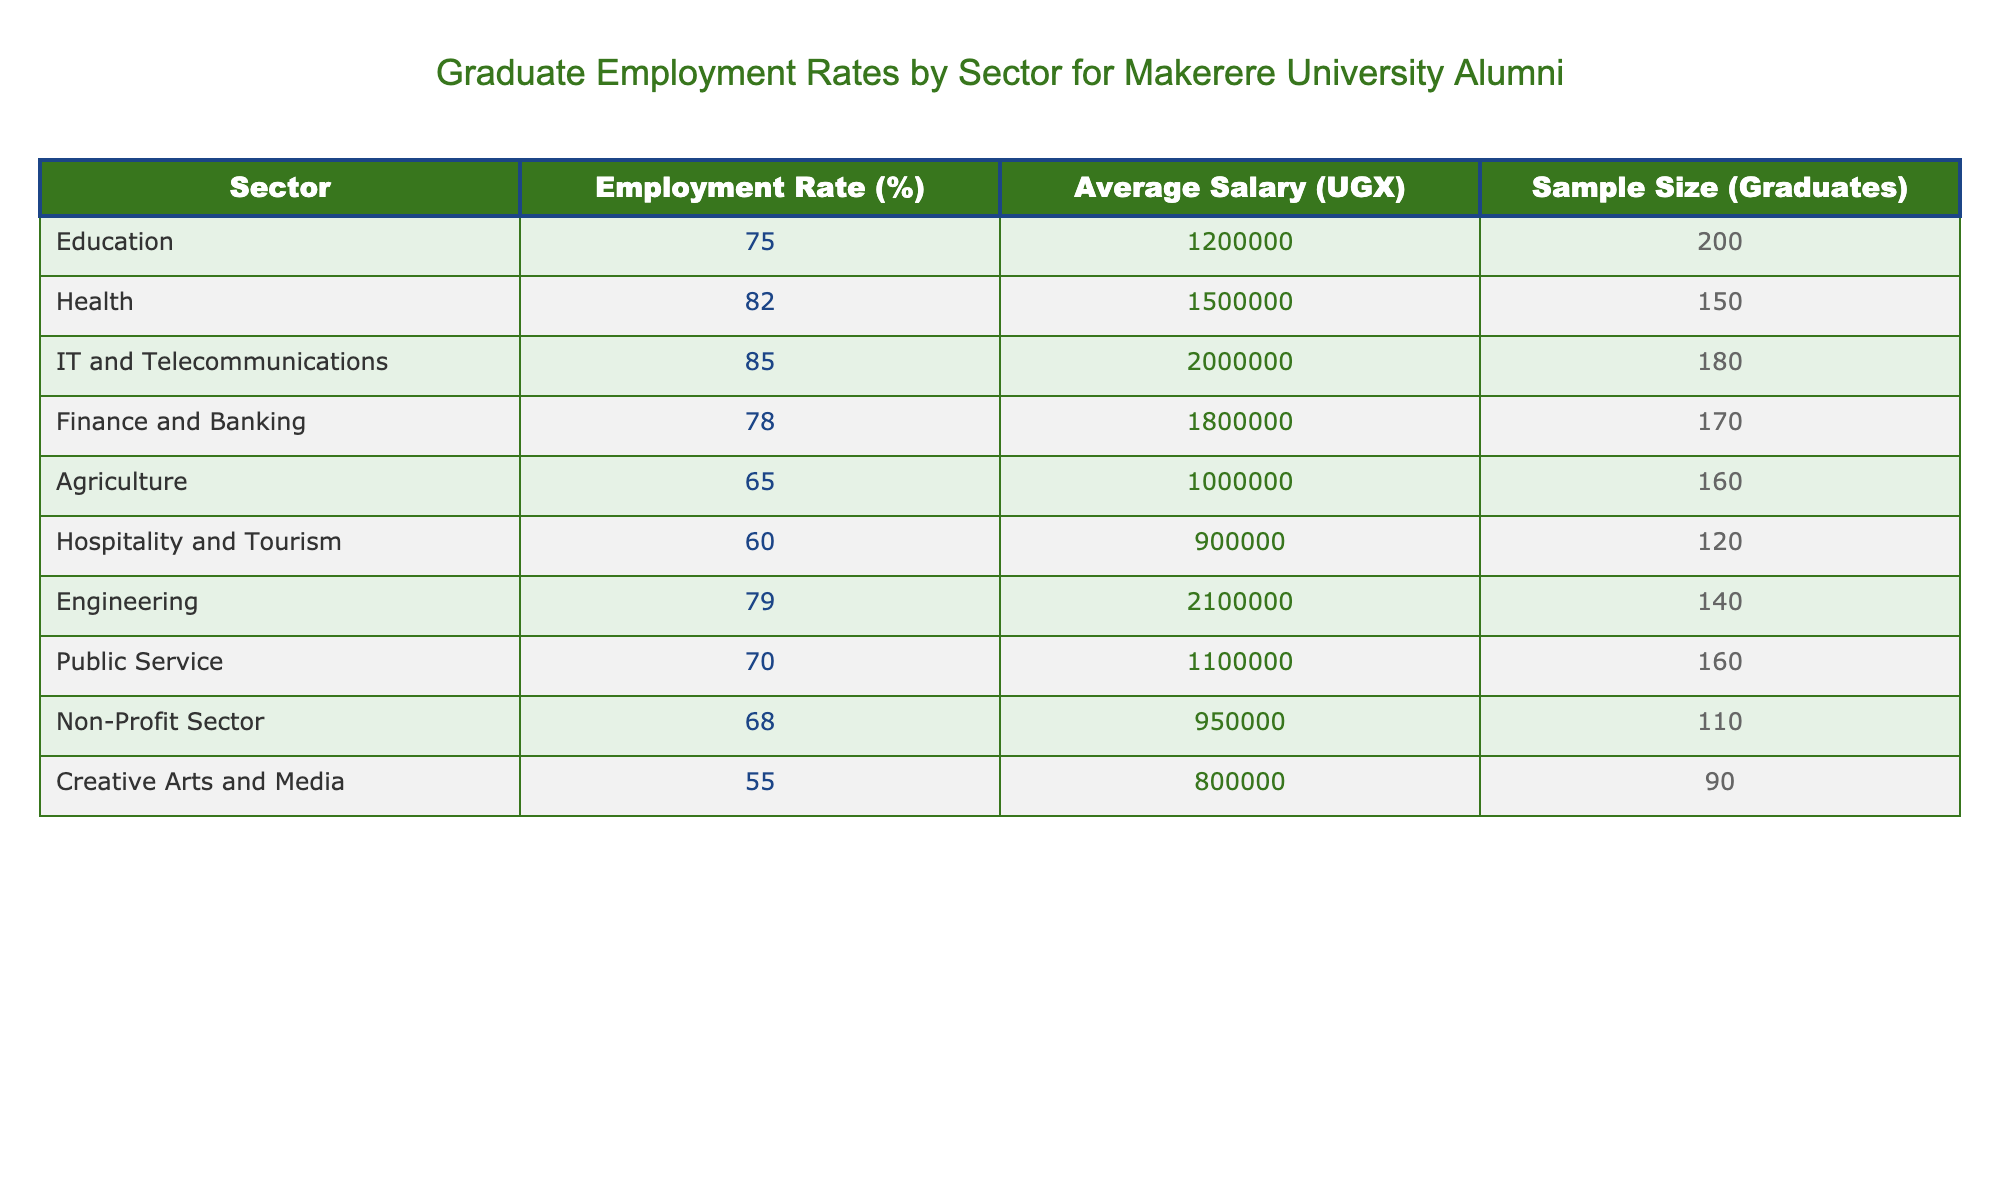What is the employment rate for the IT and Telecommunications sector? The table shows that the employment rate for the IT and Telecommunications sector is listed as 85%.
Answer: 85% Which sector has the highest average salary? The table indicates the average salaries for each sector. IT and Telecommunications has the highest average salary at 2,000,000 UGX.
Answer: 2,000,000 UGX What is the average employment rate of the Health and Public Service sectors combined? To find the average, add the employment rates of the two sectors (82% + 70% = 152%). Then, divide by 2 (152% / 2 = 76%).
Answer: 76% Is the employment rate in the Agriculture sector higher than that of the Non-Profit sector? The table shows that the employment rate for the Agriculture sector is 65% and for the Non-Profit sector is 68%, therefore, the statement is false.
Answer: No What is the total sample size of graduates from the Hospitality and Tourism, and Creative Arts and Media sectors? The sample sizes from the table are 120 for Hospitality and Tourism and 90 for Creative Arts and Media. Adding these gives a total of 120 + 90 = 210 graduates.
Answer: 210 Which sectors have an employment rate below 70%? The table lists Agriculture (65%), Hospitality and Tourism (60%), and Creative Arts and Media (55%) as sectors with employment rates below 70%.
Answer: Agriculture, Hospitality and Tourism, Creative Arts and Media What is the difference in employment rates between the highest and lowest performing sectors? The highest employment rate is 85% in IT and Telecommunications, and the lowest is 55% in Creative Arts and Media. The difference is 85% - 55% = 30%.
Answer: 30% Is the average salary in the Finance and Banking sector greater than that in the Education sector? From the table, the average salary for Finance and Banking is 1,800,000 UGX and for Education is 1,200,000 UGX. Since 1,800,000 > 1,200,000, the statement is true.
Answer: Yes 